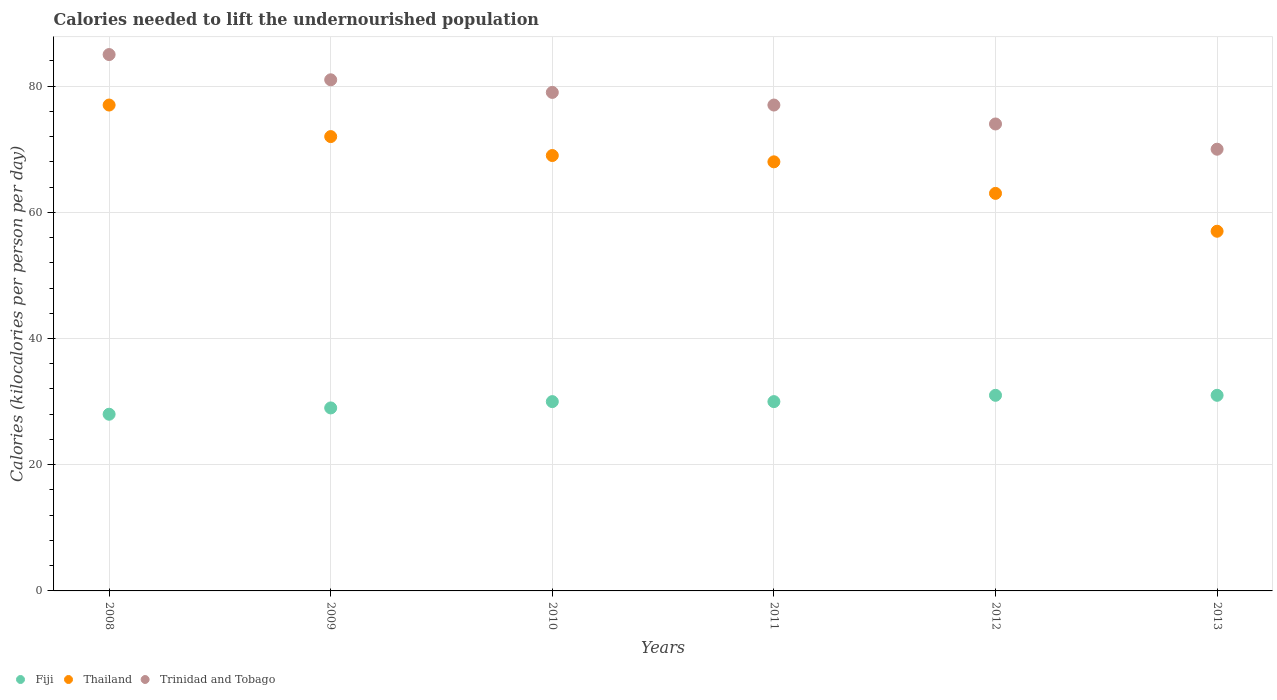How many different coloured dotlines are there?
Offer a very short reply. 3. Is the number of dotlines equal to the number of legend labels?
Ensure brevity in your answer.  Yes. What is the total calories needed to lift the undernourished population in Thailand in 2008?
Provide a short and direct response. 77. Across all years, what is the maximum total calories needed to lift the undernourished population in Thailand?
Offer a very short reply. 77. Across all years, what is the minimum total calories needed to lift the undernourished population in Thailand?
Offer a very short reply. 57. What is the total total calories needed to lift the undernourished population in Trinidad and Tobago in the graph?
Give a very brief answer. 466. What is the difference between the total calories needed to lift the undernourished population in Fiji in 2013 and the total calories needed to lift the undernourished population in Thailand in 2008?
Offer a terse response. -46. What is the average total calories needed to lift the undernourished population in Trinidad and Tobago per year?
Provide a short and direct response. 77.67. In the year 2013, what is the difference between the total calories needed to lift the undernourished population in Fiji and total calories needed to lift the undernourished population in Trinidad and Tobago?
Ensure brevity in your answer.  -39. In how many years, is the total calories needed to lift the undernourished population in Fiji greater than 52 kilocalories?
Offer a very short reply. 0. What is the ratio of the total calories needed to lift the undernourished population in Trinidad and Tobago in 2008 to that in 2013?
Ensure brevity in your answer.  1.21. Is the difference between the total calories needed to lift the undernourished population in Fiji in 2009 and 2012 greater than the difference between the total calories needed to lift the undernourished population in Trinidad and Tobago in 2009 and 2012?
Your response must be concise. No. What is the difference between the highest and the lowest total calories needed to lift the undernourished population in Thailand?
Provide a succinct answer. 20. Is the sum of the total calories needed to lift the undernourished population in Fiji in 2010 and 2012 greater than the maximum total calories needed to lift the undernourished population in Thailand across all years?
Provide a short and direct response. No. Is it the case that in every year, the sum of the total calories needed to lift the undernourished population in Thailand and total calories needed to lift the undernourished population in Trinidad and Tobago  is greater than the total calories needed to lift the undernourished population in Fiji?
Offer a terse response. Yes. Does the total calories needed to lift the undernourished population in Thailand monotonically increase over the years?
Your answer should be compact. No. Is the total calories needed to lift the undernourished population in Fiji strictly greater than the total calories needed to lift the undernourished population in Trinidad and Tobago over the years?
Provide a short and direct response. No. Is the total calories needed to lift the undernourished population in Fiji strictly less than the total calories needed to lift the undernourished population in Thailand over the years?
Your answer should be compact. Yes. Does the graph contain grids?
Your answer should be very brief. Yes. How many legend labels are there?
Ensure brevity in your answer.  3. What is the title of the graph?
Offer a terse response. Calories needed to lift the undernourished population. What is the label or title of the X-axis?
Give a very brief answer. Years. What is the label or title of the Y-axis?
Your response must be concise. Calories (kilocalories per person per day). What is the Calories (kilocalories per person per day) of Fiji in 2008?
Ensure brevity in your answer.  28. What is the Calories (kilocalories per person per day) in Thailand in 2008?
Ensure brevity in your answer.  77. What is the Calories (kilocalories per person per day) in Fiji in 2009?
Offer a very short reply. 29. What is the Calories (kilocalories per person per day) in Fiji in 2010?
Offer a terse response. 30. What is the Calories (kilocalories per person per day) in Thailand in 2010?
Provide a short and direct response. 69. What is the Calories (kilocalories per person per day) in Trinidad and Tobago in 2010?
Give a very brief answer. 79. What is the Calories (kilocalories per person per day) in Fiji in 2011?
Keep it short and to the point. 30. What is the Calories (kilocalories per person per day) in Thailand in 2012?
Provide a succinct answer. 63. What is the Calories (kilocalories per person per day) of Trinidad and Tobago in 2012?
Provide a short and direct response. 74. What is the Calories (kilocalories per person per day) of Thailand in 2013?
Offer a very short reply. 57. Across all years, what is the maximum Calories (kilocalories per person per day) in Thailand?
Your response must be concise. 77. Across all years, what is the minimum Calories (kilocalories per person per day) of Thailand?
Keep it short and to the point. 57. Across all years, what is the minimum Calories (kilocalories per person per day) of Trinidad and Tobago?
Make the answer very short. 70. What is the total Calories (kilocalories per person per day) in Fiji in the graph?
Offer a very short reply. 179. What is the total Calories (kilocalories per person per day) of Thailand in the graph?
Your answer should be compact. 406. What is the total Calories (kilocalories per person per day) of Trinidad and Tobago in the graph?
Your answer should be very brief. 466. What is the difference between the Calories (kilocalories per person per day) in Thailand in 2008 and that in 2010?
Give a very brief answer. 8. What is the difference between the Calories (kilocalories per person per day) of Trinidad and Tobago in 2008 and that in 2010?
Your answer should be very brief. 6. What is the difference between the Calories (kilocalories per person per day) of Thailand in 2008 and that in 2012?
Offer a terse response. 14. What is the difference between the Calories (kilocalories per person per day) in Thailand in 2008 and that in 2013?
Make the answer very short. 20. What is the difference between the Calories (kilocalories per person per day) of Fiji in 2009 and that in 2010?
Your response must be concise. -1. What is the difference between the Calories (kilocalories per person per day) in Thailand in 2009 and that in 2010?
Your response must be concise. 3. What is the difference between the Calories (kilocalories per person per day) of Fiji in 2009 and that in 2011?
Your response must be concise. -1. What is the difference between the Calories (kilocalories per person per day) in Thailand in 2009 and that in 2011?
Your answer should be compact. 4. What is the difference between the Calories (kilocalories per person per day) in Fiji in 2009 and that in 2012?
Provide a succinct answer. -2. What is the difference between the Calories (kilocalories per person per day) of Trinidad and Tobago in 2009 and that in 2012?
Give a very brief answer. 7. What is the difference between the Calories (kilocalories per person per day) in Fiji in 2009 and that in 2013?
Your response must be concise. -2. What is the difference between the Calories (kilocalories per person per day) in Trinidad and Tobago in 2009 and that in 2013?
Provide a short and direct response. 11. What is the difference between the Calories (kilocalories per person per day) of Fiji in 2010 and that in 2011?
Your response must be concise. 0. What is the difference between the Calories (kilocalories per person per day) in Thailand in 2010 and that in 2011?
Make the answer very short. 1. What is the difference between the Calories (kilocalories per person per day) in Trinidad and Tobago in 2010 and that in 2011?
Your answer should be compact. 2. What is the difference between the Calories (kilocalories per person per day) of Fiji in 2010 and that in 2013?
Keep it short and to the point. -1. What is the difference between the Calories (kilocalories per person per day) of Thailand in 2011 and that in 2012?
Offer a very short reply. 5. What is the difference between the Calories (kilocalories per person per day) of Trinidad and Tobago in 2011 and that in 2012?
Keep it short and to the point. 3. What is the difference between the Calories (kilocalories per person per day) of Fiji in 2012 and that in 2013?
Give a very brief answer. 0. What is the difference between the Calories (kilocalories per person per day) of Thailand in 2012 and that in 2013?
Offer a very short reply. 6. What is the difference between the Calories (kilocalories per person per day) of Trinidad and Tobago in 2012 and that in 2013?
Your response must be concise. 4. What is the difference between the Calories (kilocalories per person per day) of Fiji in 2008 and the Calories (kilocalories per person per day) of Thailand in 2009?
Your answer should be very brief. -44. What is the difference between the Calories (kilocalories per person per day) in Fiji in 2008 and the Calories (kilocalories per person per day) in Trinidad and Tobago in 2009?
Make the answer very short. -53. What is the difference between the Calories (kilocalories per person per day) in Thailand in 2008 and the Calories (kilocalories per person per day) in Trinidad and Tobago in 2009?
Your answer should be very brief. -4. What is the difference between the Calories (kilocalories per person per day) in Fiji in 2008 and the Calories (kilocalories per person per day) in Thailand in 2010?
Provide a short and direct response. -41. What is the difference between the Calories (kilocalories per person per day) in Fiji in 2008 and the Calories (kilocalories per person per day) in Trinidad and Tobago in 2010?
Your answer should be compact. -51. What is the difference between the Calories (kilocalories per person per day) in Thailand in 2008 and the Calories (kilocalories per person per day) in Trinidad and Tobago in 2010?
Provide a short and direct response. -2. What is the difference between the Calories (kilocalories per person per day) of Fiji in 2008 and the Calories (kilocalories per person per day) of Thailand in 2011?
Keep it short and to the point. -40. What is the difference between the Calories (kilocalories per person per day) in Fiji in 2008 and the Calories (kilocalories per person per day) in Trinidad and Tobago in 2011?
Provide a short and direct response. -49. What is the difference between the Calories (kilocalories per person per day) in Thailand in 2008 and the Calories (kilocalories per person per day) in Trinidad and Tobago in 2011?
Make the answer very short. 0. What is the difference between the Calories (kilocalories per person per day) of Fiji in 2008 and the Calories (kilocalories per person per day) of Thailand in 2012?
Your answer should be compact. -35. What is the difference between the Calories (kilocalories per person per day) in Fiji in 2008 and the Calories (kilocalories per person per day) in Trinidad and Tobago in 2012?
Make the answer very short. -46. What is the difference between the Calories (kilocalories per person per day) in Thailand in 2008 and the Calories (kilocalories per person per day) in Trinidad and Tobago in 2012?
Provide a short and direct response. 3. What is the difference between the Calories (kilocalories per person per day) of Fiji in 2008 and the Calories (kilocalories per person per day) of Thailand in 2013?
Your answer should be compact. -29. What is the difference between the Calories (kilocalories per person per day) in Fiji in 2008 and the Calories (kilocalories per person per day) in Trinidad and Tobago in 2013?
Keep it short and to the point. -42. What is the difference between the Calories (kilocalories per person per day) of Thailand in 2009 and the Calories (kilocalories per person per day) of Trinidad and Tobago in 2010?
Make the answer very short. -7. What is the difference between the Calories (kilocalories per person per day) in Fiji in 2009 and the Calories (kilocalories per person per day) in Thailand in 2011?
Your response must be concise. -39. What is the difference between the Calories (kilocalories per person per day) in Fiji in 2009 and the Calories (kilocalories per person per day) in Trinidad and Tobago in 2011?
Your response must be concise. -48. What is the difference between the Calories (kilocalories per person per day) in Thailand in 2009 and the Calories (kilocalories per person per day) in Trinidad and Tobago in 2011?
Ensure brevity in your answer.  -5. What is the difference between the Calories (kilocalories per person per day) of Fiji in 2009 and the Calories (kilocalories per person per day) of Thailand in 2012?
Provide a short and direct response. -34. What is the difference between the Calories (kilocalories per person per day) in Fiji in 2009 and the Calories (kilocalories per person per day) in Trinidad and Tobago in 2012?
Your response must be concise. -45. What is the difference between the Calories (kilocalories per person per day) of Thailand in 2009 and the Calories (kilocalories per person per day) of Trinidad and Tobago in 2012?
Your response must be concise. -2. What is the difference between the Calories (kilocalories per person per day) in Fiji in 2009 and the Calories (kilocalories per person per day) in Trinidad and Tobago in 2013?
Give a very brief answer. -41. What is the difference between the Calories (kilocalories per person per day) in Fiji in 2010 and the Calories (kilocalories per person per day) in Thailand in 2011?
Your response must be concise. -38. What is the difference between the Calories (kilocalories per person per day) of Fiji in 2010 and the Calories (kilocalories per person per day) of Trinidad and Tobago in 2011?
Give a very brief answer. -47. What is the difference between the Calories (kilocalories per person per day) of Fiji in 2010 and the Calories (kilocalories per person per day) of Thailand in 2012?
Your response must be concise. -33. What is the difference between the Calories (kilocalories per person per day) of Fiji in 2010 and the Calories (kilocalories per person per day) of Trinidad and Tobago in 2012?
Your answer should be compact. -44. What is the difference between the Calories (kilocalories per person per day) of Thailand in 2010 and the Calories (kilocalories per person per day) of Trinidad and Tobago in 2013?
Provide a short and direct response. -1. What is the difference between the Calories (kilocalories per person per day) of Fiji in 2011 and the Calories (kilocalories per person per day) of Thailand in 2012?
Make the answer very short. -33. What is the difference between the Calories (kilocalories per person per day) of Fiji in 2011 and the Calories (kilocalories per person per day) of Trinidad and Tobago in 2012?
Provide a short and direct response. -44. What is the difference between the Calories (kilocalories per person per day) in Thailand in 2011 and the Calories (kilocalories per person per day) in Trinidad and Tobago in 2012?
Your answer should be very brief. -6. What is the difference between the Calories (kilocalories per person per day) in Fiji in 2011 and the Calories (kilocalories per person per day) in Thailand in 2013?
Keep it short and to the point. -27. What is the difference between the Calories (kilocalories per person per day) in Fiji in 2012 and the Calories (kilocalories per person per day) in Trinidad and Tobago in 2013?
Provide a short and direct response. -39. What is the difference between the Calories (kilocalories per person per day) of Thailand in 2012 and the Calories (kilocalories per person per day) of Trinidad and Tobago in 2013?
Offer a terse response. -7. What is the average Calories (kilocalories per person per day) of Fiji per year?
Keep it short and to the point. 29.83. What is the average Calories (kilocalories per person per day) of Thailand per year?
Your answer should be very brief. 67.67. What is the average Calories (kilocalories per person per day) of Trinidad and Tobago per year?
Give a very brief answer. 77.67. In the year 2008, what is the difference between the Calories (kilocalories per person per day) of Fiji and Calories (kilocalories per person per day) of Thailand?
Your answer should be compact. -49. In the year 2008, what is the difference between the Calories (kilocalories per person per day) in Fiji and Calories (kilocalories per person per day) in Trinidad and Tobago?
Make the answer very short. -57. In the year 2009, what is the difference between the Calories (kilocalories per person per day) in Fiji and Calories (kilocalories per person per day) in Thailand?
Offer a terse response. -43. In the year 2009, what is the difference between the Calories (kilocalories per person per day) in Fiji and Calories (kilocalories per person per day) in Trinidad and Tobago?
Make the answer very short. -52. In the year 2009, what is the difference between the Calories (kilocalories per person per day) in Thailand and Calories (kilocalories per person per day) in Trinidad and Tobago?
Offer a very short reply. -9. In the year 2010, what is the difference between the Calories (kilocalories per person per day) of Fiji and Calories (kilocalories per person per day) of Thailand?
Offer a very short reply. -39. In the year 2010, what is the difference between the Calories (kilocalories per person per day) of Fiji and Calories (kilocalories per person per day) of Trinidad and Tobago?
Keep it short and to the point. -49. In the year 2010, what is the difference between the Calories (kilocalories per person per day) in Thailand and Calories (kilocalories per person per day) in Trinidad and Tobago?
Your answer should be compact. -10. In the year 2011, what is the difference between the Calories (kilocalories per person per day) in Fiji and Calories (kilocalories per person per day) in Thailand?
Provide a succinct answer. -38. In the year 2011, what is the difference between the Calories (kilocalories per person per day) in Fiji and Calories (kilocalories per person per day) in Trinidad and Tobago?
Make the answer very short. -47. In the year 2011, what is the difference between the Calories (kilocalories per person per day) in Thailand and Calories (kilocalories per person per day) in Trinidad and Tobago?
Your answer should be compact. -9. In the year 2012, what is the difference between the Calories (kilocalories per person per day) in Fiji and Calories (kilocalories per person per day) in Thailand?
Keep it short and to the point. -32. In the year 2012, what is the difference between the Calories (kilocalories per person per day) in Fiji and Calories (kilocalories per person per day) in Trinidad and Tobago?
Offer a terse response. -43. In the year 2012, what is the difference between the Calories (kilocalories per person per day) of Thailand and Calories (kilocalories per person per day) of Trinidad and Tobago?
Offer a terse response. -11. In the year 2013, what is the difference between the Calories (kilocalories per person per day) in Fiji and Calories (kilocalories per person per day) in Trinidad and Tobago?
Provide a succinct answer. -39. In the year 2013, what is the difference between the Calories (kilocalories per person per day) of Thailand and Calories (kilocalories per person per day) of Trinidad and Tobago?
Provide a succinct answer. -13. What is the ratio of the Calories (kilocalories per person per day) of Fiji in 2008 to that in 2009?
Make the answer very short. 0.97. What is the ratio of the Calories (kilocalories per person per day) of Thailand in 2008 to that in 2009?
Your response must be concise. 1.07. What is the ratio of the Calories (kilocalories per person per day) of Trinidad and Tobago in 2008 to that in 2009?
Give a very brief answer. 1.05. What is the ratio of the Calories (kilocalories per person per day) of Fiji in 2008 to that in 2010?
Give a very brief answer. 0.93. What is the ratio of the Calories (kilocalories per person per day) in Thailand in 2008 to that in 2010?
Give a very brief answer. 1.12. What is the ratio of the Calories (kilocalories per person per day) in Trinidad and Tobago in 2008 to that in 2010?
Provide a succinct answer. 1.08. What is the ratio of the Calories (kilocalories per person per day) of Fiji in 2008 to that in 2011?
Make the answer very short. 0.93. What is the ratio of the Calories (kilocalories per person per day) in Thailand in 2008 to that in 2011?
Keep it short and to the point. 1.13. What is the ratio of the Calories (kilocalories per person per day) in Trinidad and Tobago in 2008 to that in 2011?
Your response must be concise. 1.1. What is the ratio of the Calories (kilocalories per person per day) in Fiji in 2008 to that in 2012?
Offer a very short reply. 0.9. What is the ratio of the Calories (kilocalories per person per day) in Thailand in 2008 to that in 2012?
Ensure brevity in your answer.  1.22. What is the ratio of the Calories (kilocalories per person per day) of Trinidad and Tobago in 2008 to that in 2012?
Ensure brevity in your answer.  1.15. What is the ratio of the Calories (kilocalories per person per day) in Fiji in 2008 to that in 2013?
Give a very brief answer. 0.9. What is the ratio of the Calories (kilocalories per person per day) of Thailand in 2008 to that in 2013?
Offer a terse response. 1.35. What is the ratio of the Calories (kilocalories per person per day) in Trinidad and Tobago in 2008 to that in 2013?
Give a very brief answer. 1.21. What is the ratio of the Calories (kilocalories per person per day) of Fiji in 2009 to that in 2010?
Offer a terse response. 0.97. What is the ratio of the Calories (kilocalories per person per day) of Thailand in 2009 to that in 2010?
Your answer should be compact. 1.04. What is the ratio of the Calories (kilocalories per person per day) in Trinidad and Tobago in 2009 to that in 2010?
Offer a terse response. 1.03. What is the ratio of the Calories (kilocalories per person per day) in Fiji in 2009 to that in 2011?
Give a very brief answer. 0.97. What is the ratio of the Calories (kilocalories per person per day) of Thailand in 2009 to that in 2011?
Your answer should be compact. 1.06. What is the ratio of the Calories (kilocalories per person per day) in Trinidad and Tobago in 2009 to that in 2011?
Offer a terse response. 1.05. What is the ratio of the Calories (kilocalories per person per day) in Fiji in 2009 to that in 2012?
Give a very brief answer. 0.94. What is the ratio of the Calories (kilocalories per person per day) of Trinidad and Tobago in 2009 to that in 2012?
Offer a terse response. 1.09. What is the ratio of the Calories (kilocalories per person per day) of Fiji in 2009 to that in 2013?
Offer a very short reply. 0.94. What is the ratio of the Calories (kilocalories per person per day) of Thailand in 2009 to that in 2013?
Keep it short and to the point. 1.26. What is the ratio of the Calories (kilocalories per person per day) in Trinidad and Tobago in 2009 to that in 2013?
Keep it short and to the point. 1.16. What is the ratio of the Calories (kilocalories per person per day) in Thailand in 2010 to that in 2011?
Your answer should be compact. 1.01. What is the ratio of the Calories (kilocalories per person per day) in Thailand in 2010 to that in 2012?
Your answer should be compact. 1.1. What is the ratio of the Calories (kilocalories per person per day) in Trinidad and Tobago in 2010 to that in 2012?
Your response must be concise. 1.07. What is the ratio of the Calories (kilocalories per person per day) of Fiji in 2010 to that in 2013?
Give a very brief answer. 0.97. What is the ratio of the Calories (kilocalories per person per day) in Thailand in 2010 to that in 2013?
Ensure brevity in your answer.  1.21. What is the ratio of the Calories (kilocalories per person per day) of Trinidad and Tobago in 2010 to that in 2013?
Provide a succinct answer. 1.13. What is the ratio of the Calories (kilocalories per person per day) of Fiji in 2011 to that in 2012?
Keep it short and to the point. 0.97. What is the ratio of the Calories (kilocalories per person per day) of Thailand in 2011 to that in 2012?
Provide a short and direct response. 1.08. What is the ratio of the Calories (kilocalories per person per day) in Trinidad and Tobago in 2011 to that in 2012?
Provide a short and direct response. 1.04. What is the ratio of the Calories (kilocalories per person per day) in Thailand in 2011 to that in 2013?
Your answer should be very brief. 1.19. What is the ratio of the Calories (kilocalories per person per day) in Fiji in 2012 to that in 2013?
Offer a very short reply. 1. What is the ratio of the Calories (kilocalories per person per day) in Thailand in 2012 to that in 2013?
Provide a short and direct response. 1.11. What is the ratio of the Calories (kilocalories per person per day) in Trinidad and Tobago in 2012 to that in 2013?
Your answer should be compact. 1.06. What is the difference between the highest and the second highest Calories (kilocalories per person per day) of Trinidad and Tobago?
Keep it short and to the point. 4. What is the difference between the highest and the lowest Calories (kilocalories per person per day) in Trinidad and Tobago?
Offer a terse response. 15. 